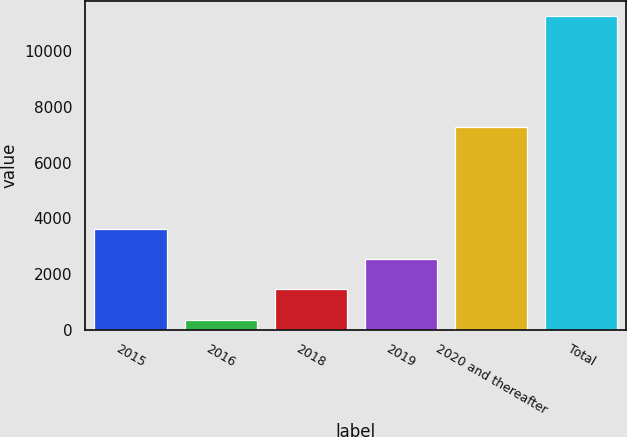Convert chart to OTSL. <chart><loc_0><loc_0><loc_500><loc_500><bar_chart><fcel>2015<fcel>2016<fcel>2018<fcel>2019<fcel>2020 and thereafter<fcel>Total<nl><fcel>3622.1<fcel>350<fcel>1440.7<fcel>2531.4<fcel>7263<fcel>11257<nl></chart> 